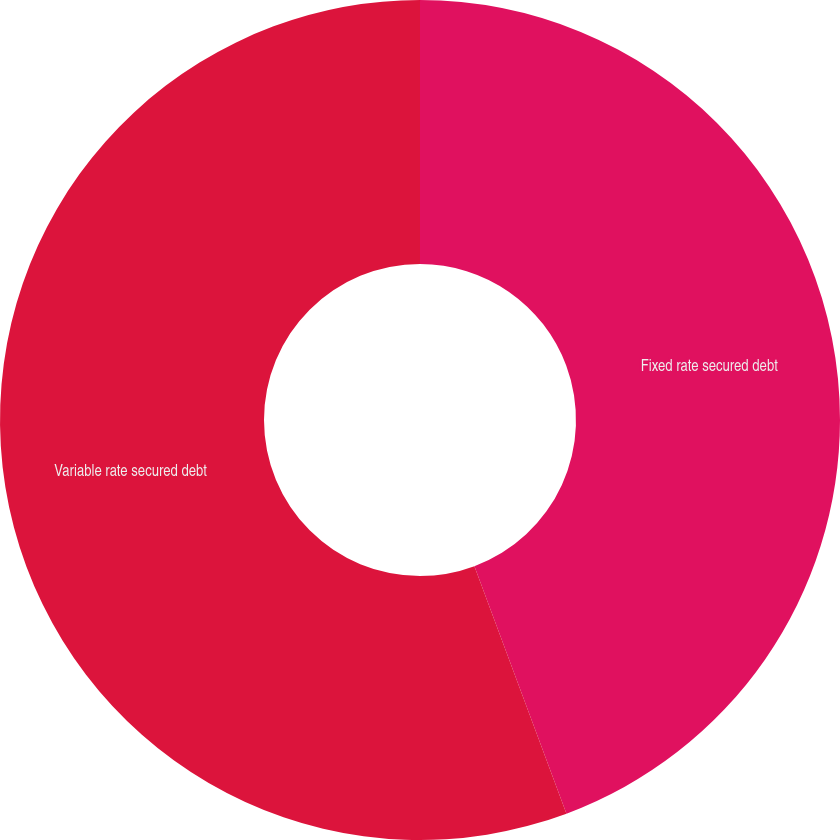Convert chart. <chart><loc_0><loc_0><loc_500><loc_500><pie_chart><fcel>Fixed rate secured debt<fcel>Variable rate secured debt<nl><fcel>44.33%<fcel>55.67%<nl></chart> 